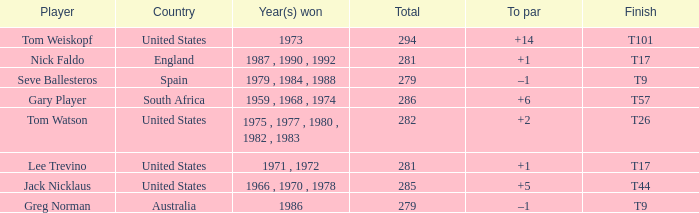Which country had a total of 282? United States. 